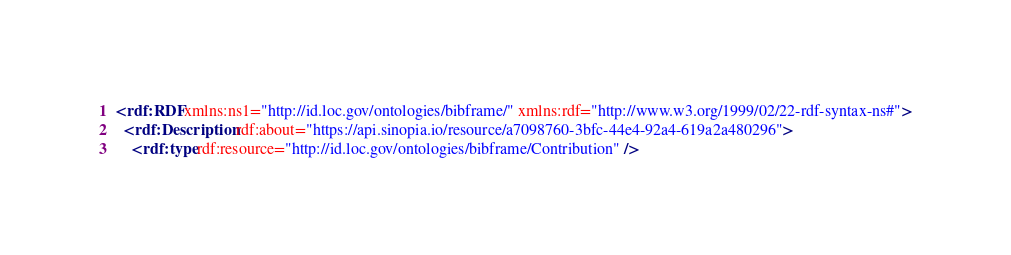<code> <loc_0><loc_0><loc_500><loc_500><_XML_><rdf:RDF xmlns:ns1="http://id.loc.gov/ontologies/bibframe/" xmlns:rdf="http://www.w3.org/1999/02/22-rdf-syntax-ns#">
  <rdf:Description rdf:about="https://api.sinopia.io/resource/a7098760-3bfc-44e4-92a4-619a2a480296">
    <rdf:type rdf:resource="http://id.loc.gov/ontologies/bibframe/Contribution" /></code> 